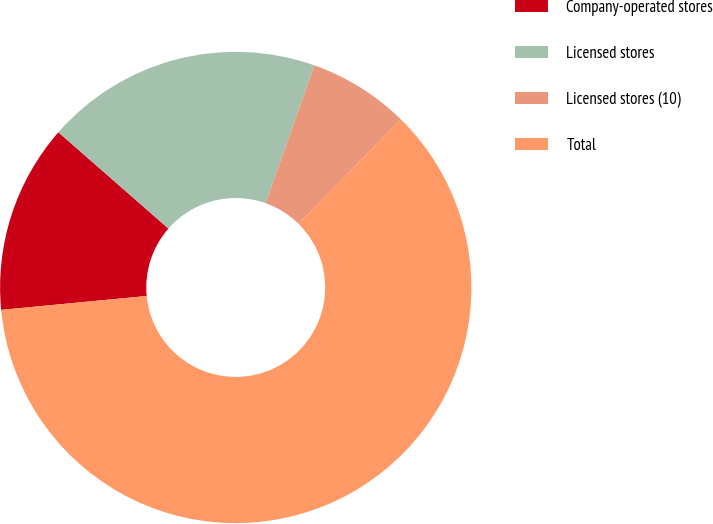<chart> <loc_0><loc_0><loc_500><loc_500><pie_chart><fcel>Company-operated stores<fcel>Licensed stores<fcel>Licensed stores (10)<fcel>Total<nl><fcel>12.96%<fcel>18.98%<fcel>6.94%<fcel>61.12%<nl></chart> 